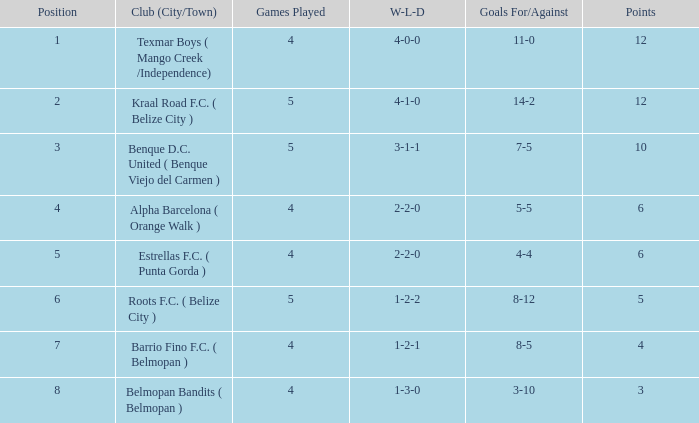What is the minimum points with goals for/against being 8-5 4.0. 